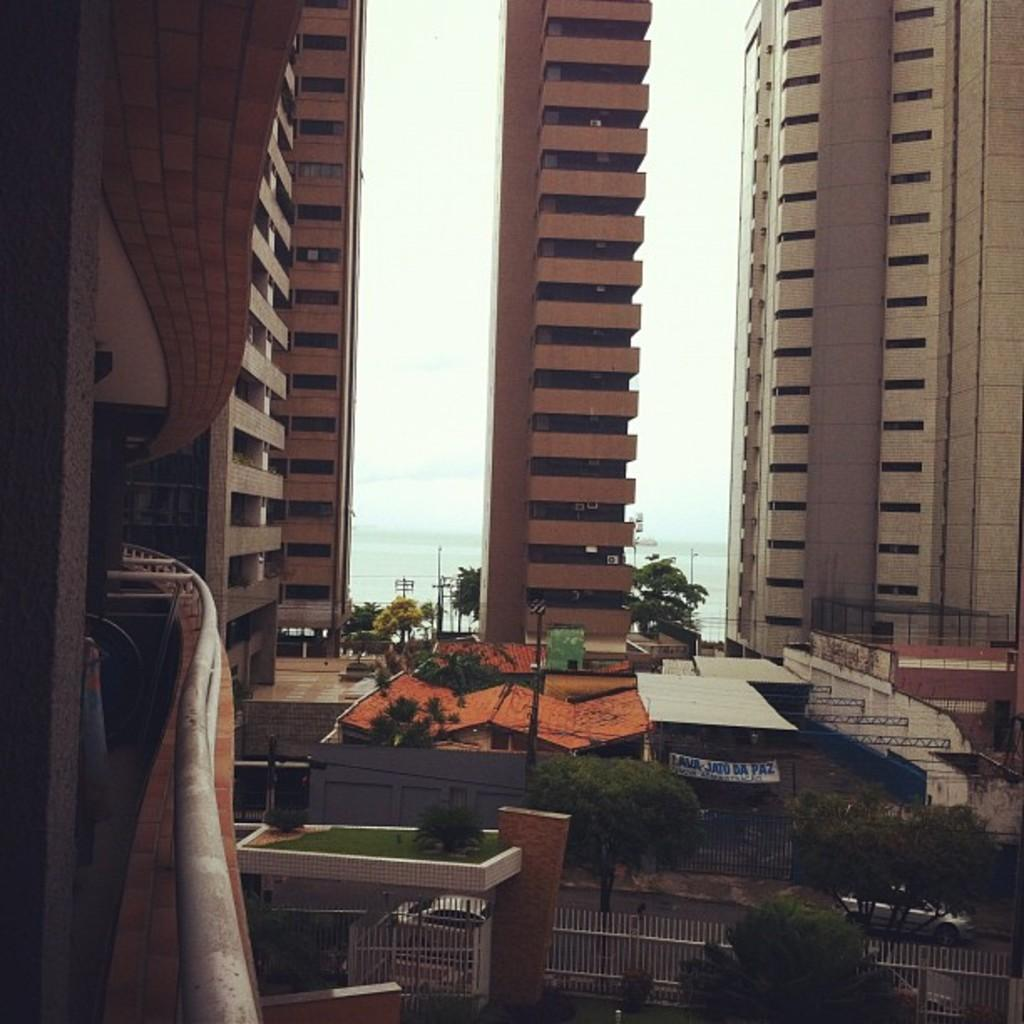What type of structures can be seen in the image? There are buildings in the image. What natural elements are present in the image? There are trees and grass visible in the image. What architectural feature can be seen in the image? The railing is visible in the image. What type of surface is present in the image? The road is present in the image. What other objects can be seen in the image? There are poles in the image. What is visible in the background of the image? The background of the image includes water and the sky. What knowledge is being shared in the image? There is no indication of knowledge being shared in the image; it primarily features buildings, trees, grass, railing, road, poles, water, and sky. What hobbies are being pursued in the image? There is no indication of any hobbies being pursued in the image; it primarily features buildings, trees, grass, railing, road, poles, water, and sky. 